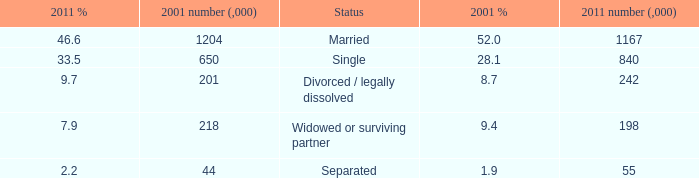What is the lowest 2011 number (,000)? 55.0. 